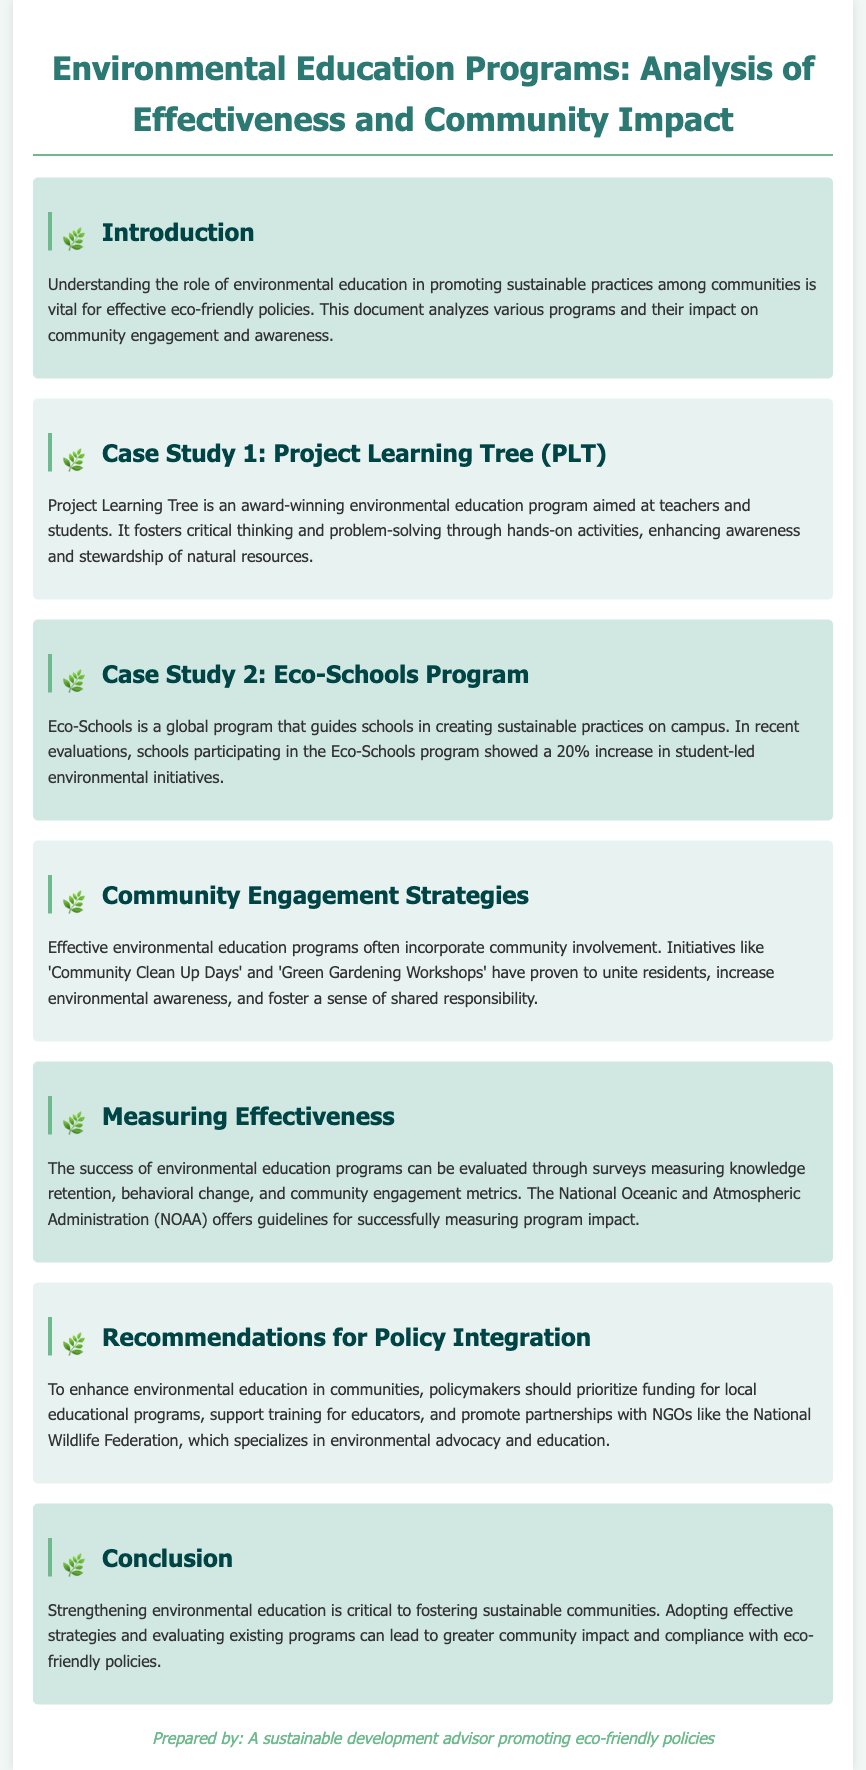what is the title of the document? The title is presented at the top of the document as the main heading.
Answer: Environmental Education Programs: Analysis of Effectiveness and Community Impact which case study focuses on an award-winning program for teachers and students? This information is stated in the section discussing the first case study.
Answer: Project Learning Tree (PLT) what is the percentage increase in student-led environmental initiatives reported by Eco-Schools? This statistic is provided in the evaluation of the Eco-Schools Program.
Answer: 20% what community involvement initiatives are mentioned in the document? The section on community engagement outlines specific initiatives that unite residents.
Answer: Community Clean Up Days and Green Gardening Workshops which organization offers guidelines for measuring program impact? The document specifically mentions this organization in the context of program evaluation.
Answer: National Oceanic and Atmospheric Administration (NOAA) what is one recommendation for policy integration regarding environmental education? Recommendations for enhancing environmental education are discussed in the relevant section.
Answer: Prioritize funding for local educational programs 